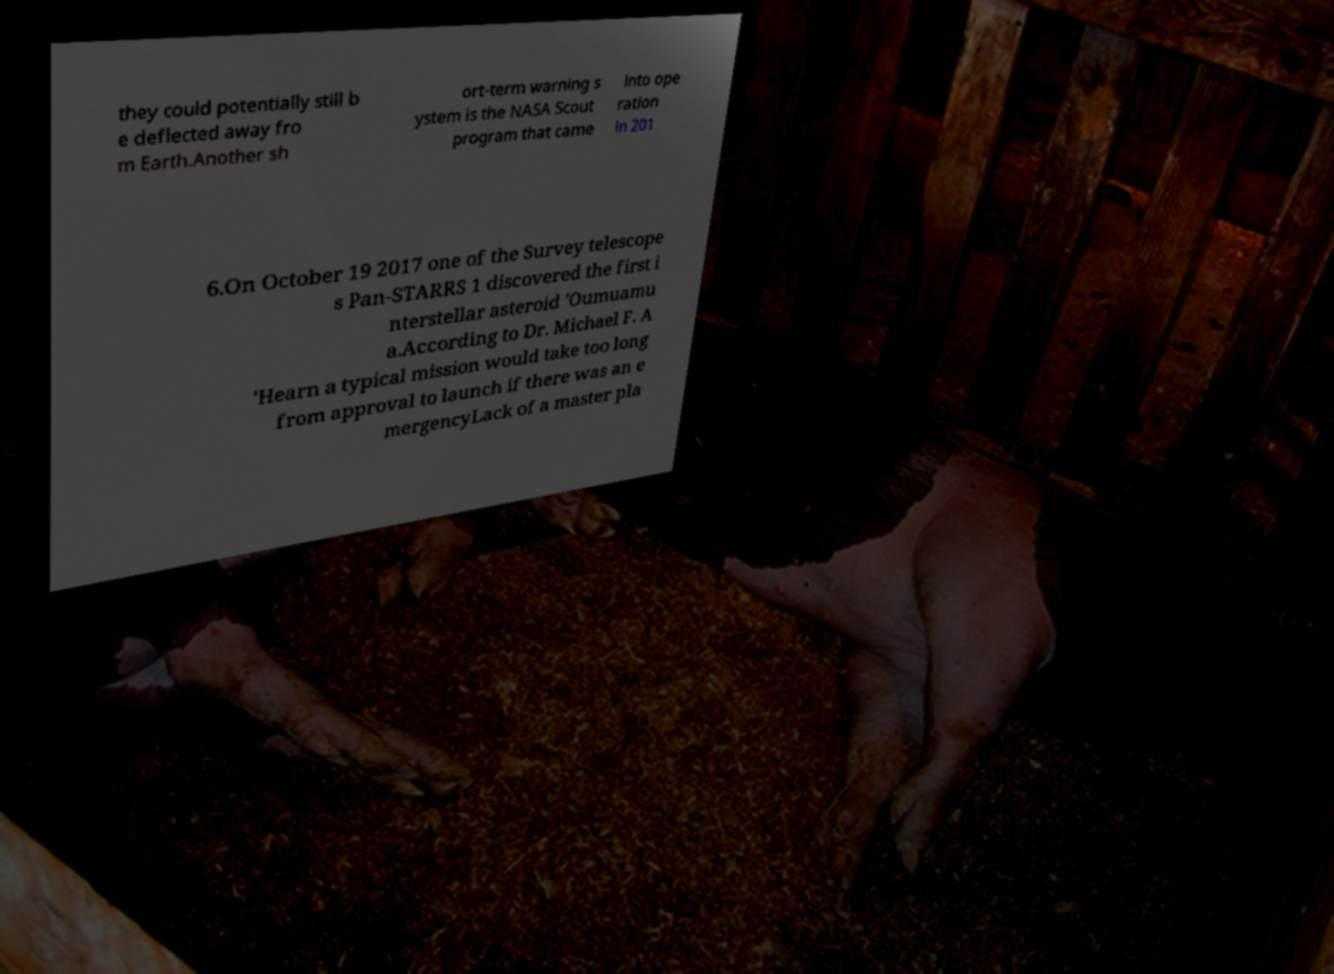There's text embedded in this image that I need extracted. Can you transcribe it verbatim? they could potentially still b e deflected away fro m Earth.Another sh ort-term warning s ystem is the NASA Scout program that came into ope ration in 201 6.On October 19 2017 one of the Survey telescope s Pan-STARRS 1 discovered the first i nterstellar asteroid 'Oumuamu a.According to Dr. Michael F. A 'Hearn a typical mission would take too long from approval to launch if there was an e mergencyLack of a master pla 